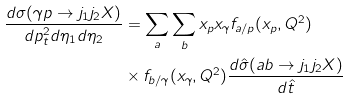Convert formula to latex. <formula><loc_0><loc_0><loc_500><loc_500>\frac { d \sigma ( \gamma p \rightarrow j _ { 1 } j _ { 2 } X ) } { d p ^ { 2 } _ { t } d \eta _ { 1 } d \eta _ { 2 } } & = \sum _ { a } \sum _ { b } x _ { p } x _ { \gamma } f _ { a / p } ( x _ { p } , Q ^ { 2 } ) \\ & \times f _ { b / \gamma } ( x _ { \gamma } , Q ^ { 2 } ) \frac { d \hat { \sigma } ( a b \rightarrow j _ { 1 } j _ { 2 } X ) } { d \hat { t } }</formula> 